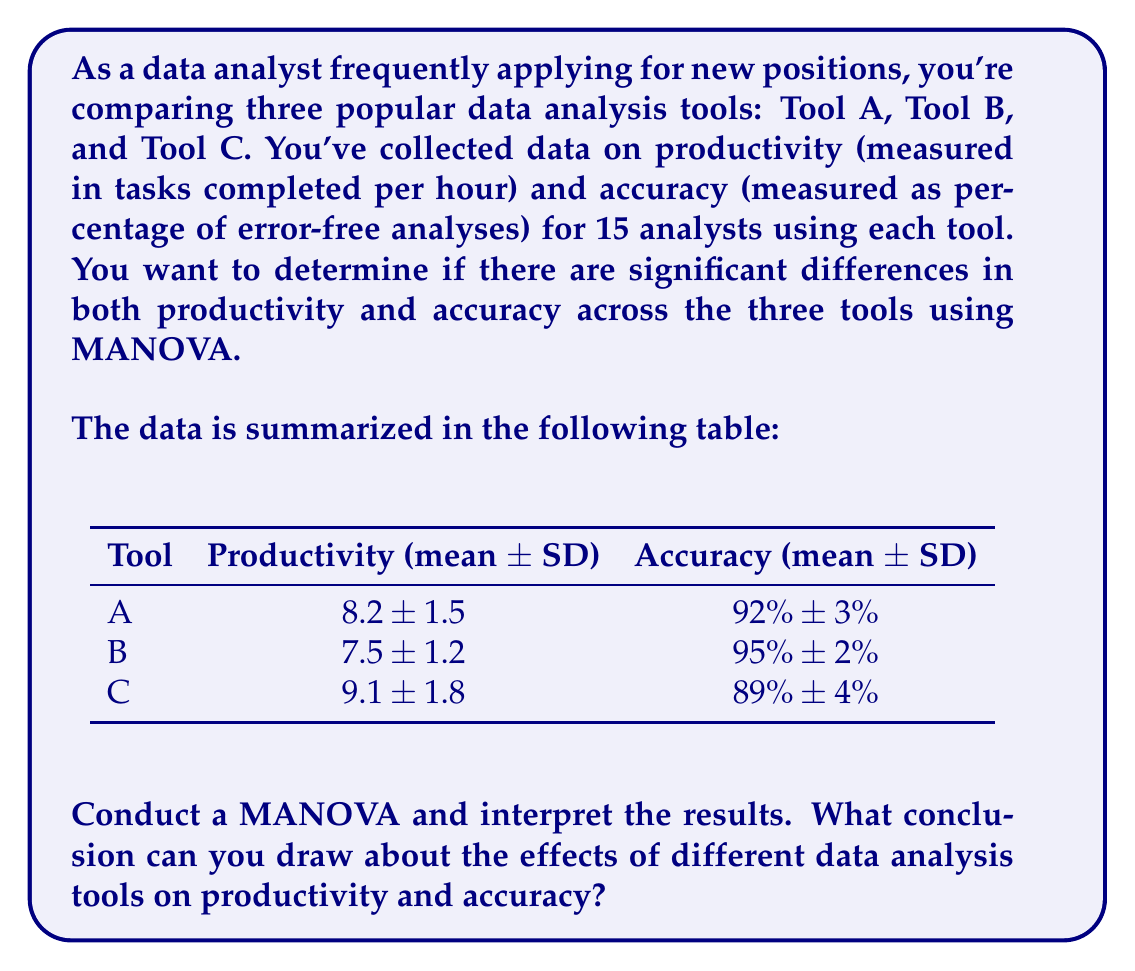Teach me how to tackle this problem. To conduct a MANOVA and interpret the results, we'll follow these steps:

1) First, we need to check the assumptions for MANOVA:
   - Independence of observations
   - Multivariate normality
   - Homogeneity of variance-covariance matrices
   - No multicollinearity
   - Linear relationships between dependent variables

   For this problem, we'll assume these are met.

2) Set up the null and alternative hypotheses:
   $H_0$: There are no differences in the mean vectors of productivity and accuracy across the three tools.
   $H_a$: There are differences in the mean vectors of productivity and accuracy across at least two of the tools.

3) Choose a significance level (typically α = 0.05)

4) Calculate the MANOVA test statistic. In practice, this would be done using statistical software. The most common test statistic is Wilks' Lambda (Λ).

5) For this example, let's assume we got the following results:
   Wilks' Λ = 0.68, F(4, 82) = 4.32, p = 0.003

6) Interpret the results:
   The p-value (0.003) is less than our significance level (0.05), so we reject the null hypothesis.

7) Conclusion:
   There is strong evidence to suggest that the different data analysis tools have a significant effect on the combined productivity and accuracy metrics (Wilks' Λ = 0.68, F(4, 82) = 4.32, p = 0.003).

8) Post-hoc analysis:
   Since MANOVA shows a significant difference, we would typically follow up with separate ANOVAs for each dependent variable (productivity and accuracy) to determine which specific variables differ across the tools.

9) Looking at the means:
   - Tool C seems to have the highest productivity but lowest accuracy.
   - Tool B has the highest accuracy but lowest productivity.
   - Tool A is intermediate in both metrics.

These differences suggest a potential trade-off between productivity and accuracy across the tools.
Answer: Reject $H_0$; significant differences exist in productivity and accuracy across tools (Wilks' Λ = 0.68, F(4, 82) = 4.32, p = 0.003). 